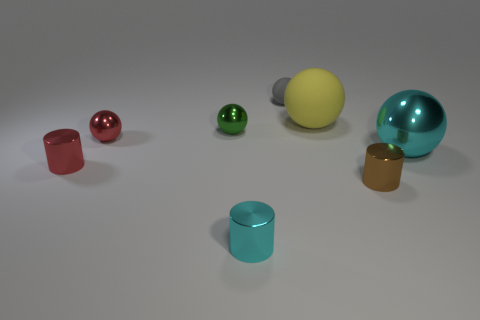Is there a small red object made of the same material as the small cyan object?
Offer a terse response. Yes. There is a cyan cylinder that is the same size as the brown cylinder; what material is it?
Make the answer very short. Metal. Do the red cylinder and the small cyan thing have the same material?
Keep it short and to the point. Yes. What number of things are either metal balls or large yellow matte spheres?
Your answer should be very brief. 4. There is a big object that is in front of the large rubber sphere; what is its shape?
Ensure brevity in your answer.  Sphere. There is a big object that is the same material as the green sphere; what is its color?
Your answer should be very brief. Cyan. There is a gray thing that is the same shape as the large yellow object; what material is it?
Ensure brevity in your answer.  Rubber. What shape is the tiny cyan object?
Your answer should be very brief. Cylinder. What is the material of the ball that is to the right of the gray object and in front of the yellow rubber sphere?
Give a very brief answer. Metal. The gray thing that is made of the same material as the yellow sphere is what shape?
Your answer should be very brief. Sphere. 